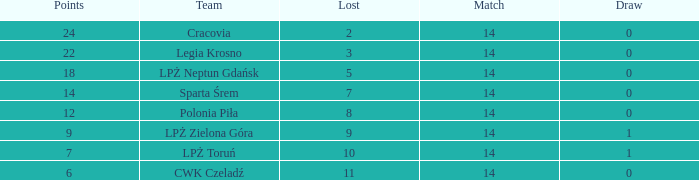What is the sum for the match with a draw less than 0? None. 